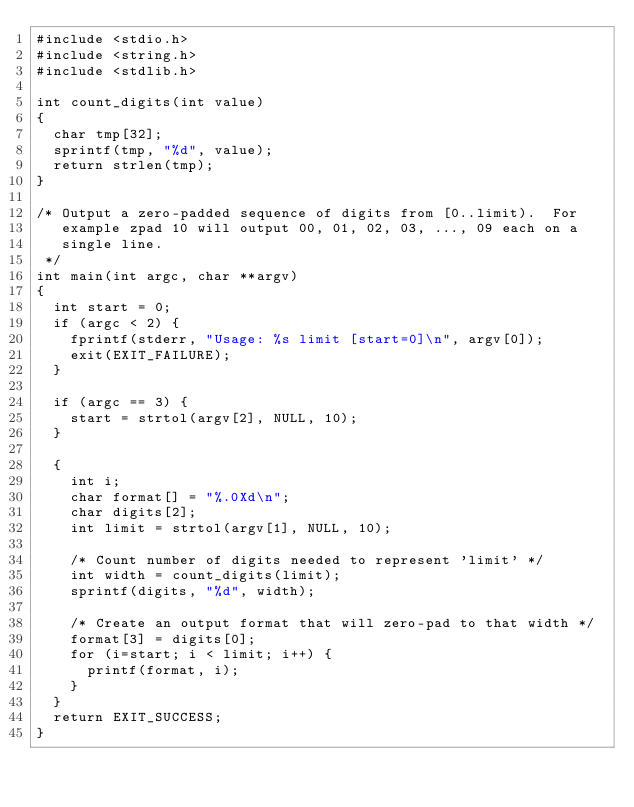<code> <loc_0><loc_0><loc_500><loc_500><_C_>#include <stdio.h>
#include <string.h>
#include <stdlib.h>

int count_digits(int value)
{
  char tmp[32];
  sprintf(tmp, "%d", value);
  return strlen(tmp);
}

/* Output a zero-padded sequence of digits from [0..limit).  For
   example zpad 10 will output 00, 01, 02, 03, ..., 09 each on a
   single line.
 */
int main(int argc, char **argv)
{
  int start = 0;
  if (argc < 2) {
    fprintf(stderr, "Usage: %s limit [start=0]\n", argv[0]);
    exit(EXIT_FAILURE);
  }

  if (argc == 3) {
    start = strtol(argv[2], NULL, 10);
  }
  
  {
    int i;
    char format[] = "%.0Xd\n";
    char digits[2];
    int limit = strtol(argv[1], NULL, 10);

    /* Count number of digits needed to represent 'limit' */
    int width = count_digits(limit);
    sprintf(digits, "%d", width);

    /* Create an output format that will zero-pad to that width */
    format[3] = digits[0];
    for (i=start; i < limit; i++) {
      printf(format, i);
    }
  }
  return EXIT_SUCCESS;
}
</code> 